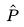Convert formula to latex. <formula><loc_0><loc_0><loc_500><loc_500>\hat { P }</formula> 